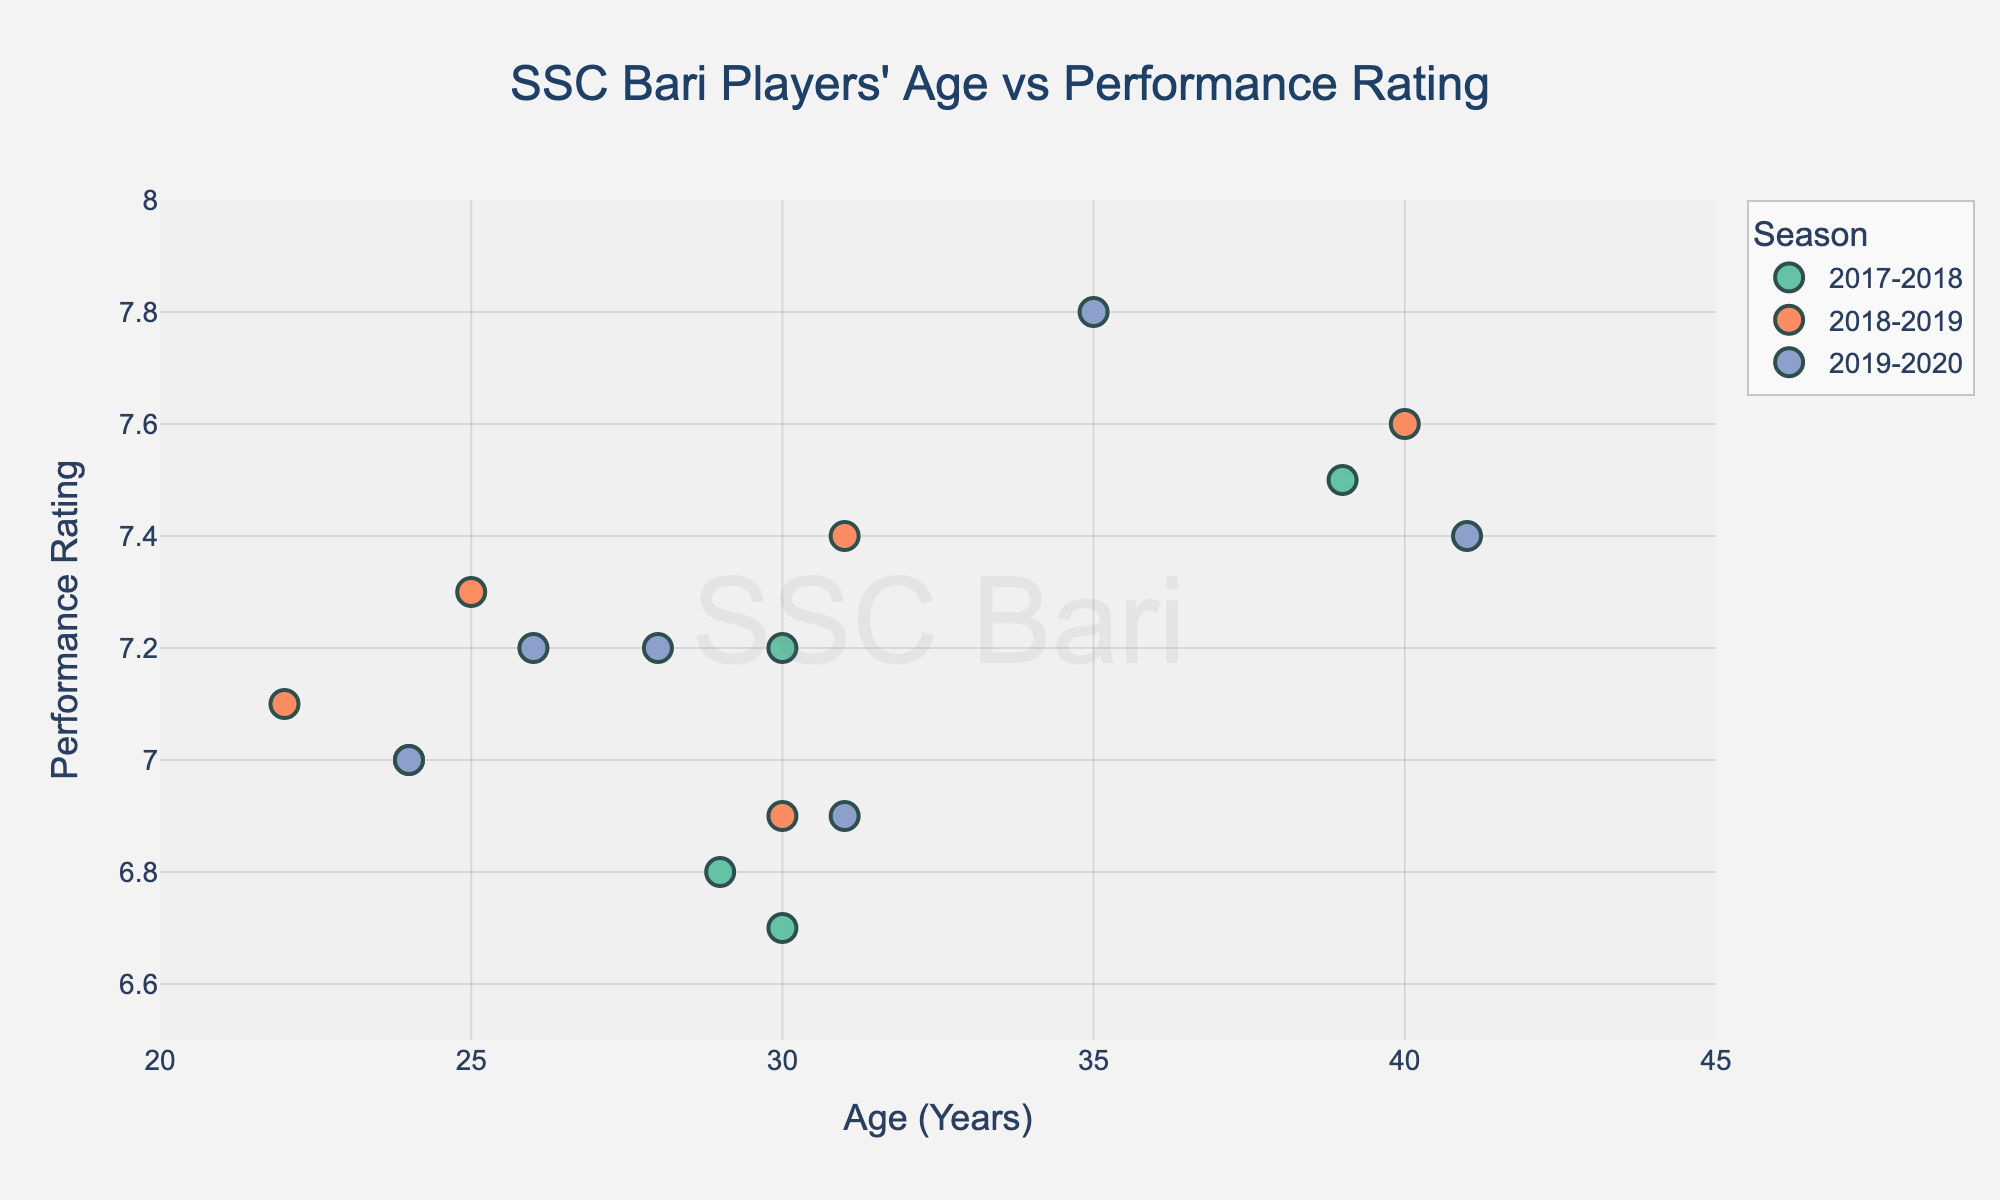What is the title of the figure? The title of a figure is usually placed at the top of the plot. In this case, it reads "SSC Bari Players' Age vs Performance Rating".
Answer: "SSC Bari Players' Age vs Performance Rating" What is the performance rating of the oldest player in the 2017-2018 season? To find the oldest player in the 2017-2018 season, look for the highest age value within that season. The oldest player in 2017-2018 is Franco Brienza, aged 39, and his performance rating is 7.5.
Answer: 7.5 How many players are represented in the 2019-2020 season? Count the number of data points corresponding to the 2019-2020 season. There are five players: Franco Brienza, Mirco Antenucci, Michele Scienza, Branco, and Marco Perrotta.
Answer: 5 Whose performance rating increased the most between 2017-2018 and 2018-2019? Identify players who appear in both seasons and calculate the difference in their performance ratings. Franco Brienza's rating increased from 7.5 to 7.6, and no other player's performance improved as much.
Answer: Franco Brienza What is the average performance rating of players in the 2018-2019 season? Sum the performance ratings of players in 2018-2019 and divide by the number of players. The ratings are 7.6, 6.9, 7.3, 7.4, and 7.1. The sum is 36.3, and the average is 36.3/5 = 7.26.
Answer: 7.26 Which season has the most consistent performance rating among players? For each season, evaluate the range (difference between highest and lowest rating). The ranges are:
- 2017-2018: 7.5 - 6.7 = 0.8
- 2018-2019: 7.6 - 6.9 = 0.7
- 2019-2020: 7.8 - 6.9 = 0.9
The 2018-2019 season has the smallest range.
Answer: 2018-2019 Who was the player with the highest performance rating overall, and in which season did this occur? Identify the highest performance rating in the plot and find the player associated with it. Mirco Antenucci in the 2019-2020 season has the highest rating of 7.8.
Answer: Mirco Antenucci, 2019-2020 Is there a clear correlation between age and performance rating across the seasons? Observe the scatter plot to determine if a trend (positive or negative) exists between age and performance rating. The points are scattered without a notable trend, indicating no clear correlation.
Answer: No clear correlation Which season had the highest performance rating for Franco Brienza and what was his age at the time? Find Franco Brienza in each season and compare his ratings. In the 2018-2019 season, his rating was highest at 7.6, and he was 40 years old.
Answer: 2018-2019, aged 40 How does the average performance rating of players aged 30 and above compare to those younger than 30 across all seasons? Calculate the average rating for players in both age groups:
- Aged 30+ (ratings: 7.5, 6.8, 7.2, 6.7, 7.6, 6.9, 7.4, 7.4, 6.9, 7.2, total: 72.6, average: 72.6/10 = 7.26)
- Aged <30 (ratings: 7.0, 7.3, 7.1, 7.2, 7.0, total: 35.6, average: 35.6/5 = 7.12)
Players aged 30 and above have a slightly higher average rating.
Answer: 7.26 vs 7.12 